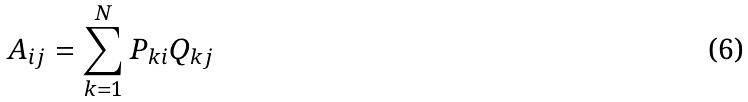Convert formula to latex. <formula><loc_0><loc_0><loc_500><loc_500>A _ { i j } = \sum _ { k = 1 } ^ { N } P _ { k i } Q _ { k j }</formula> 